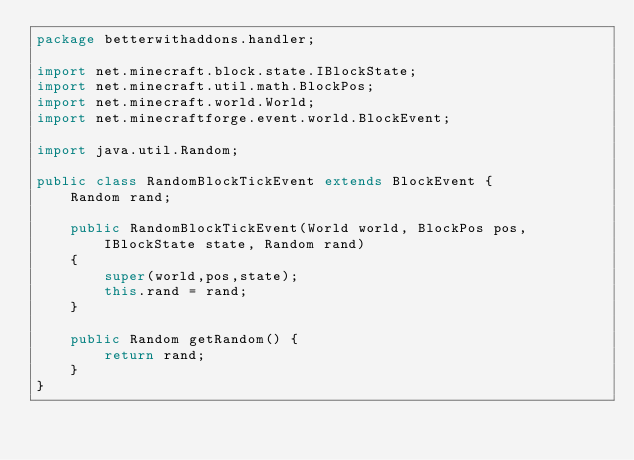<code> <loc_0><loc_0><loc_500><loc_500><_Java_>package betterwithaddons.handler;

import net.minecraft.block.state.IBlockState;
import net.minecraft.util.math.BlockPos;
import net.minecraft.world.World;
import net.minecraftforge.event.world.BlockEvent;

import java.util.Random;

public class RandomBlockTickEvent extends BlockEvent {
    Random rand;

    public RandomBlockTickEvent(World world, BlockPos pos, IBlockState state, Random rand)
    {
        super(world,pos,state);
        this.rand = rand;
    }

    public Random getRandom() {
        return rand;
    }
}
</code> 